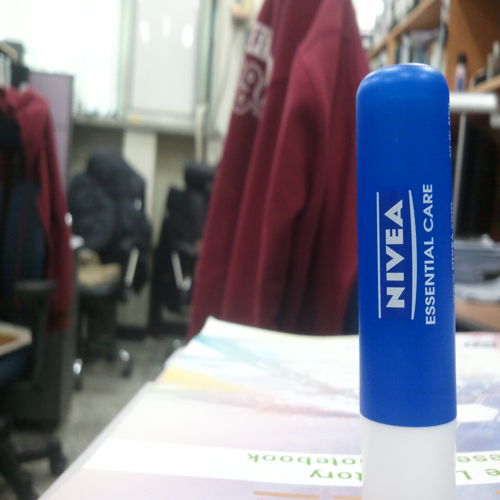Could you describe the branding strategy that seems to be conveyed through the product's design? The product's design in the image reflects Nivea's branding strategy of simplicity and reliability. The use of a clean, white label with bold, blue lettering conveys a sense of purity and trustworthiness. The minimalistic design suggests practicality and efficiency, aligning with the brand's reputation for providing essential, no-frills personal care items. What can we infer about the product's target consumer from the image? From the image, we can infer that the product is likely targeting consumers who value practicality and effectiveness. The straightforward design and presence in a workspace imply it's meant for individuals who appreciate convenient, everyday care items that they can use on the go, whether they're at work or carrying out daily tasks. 